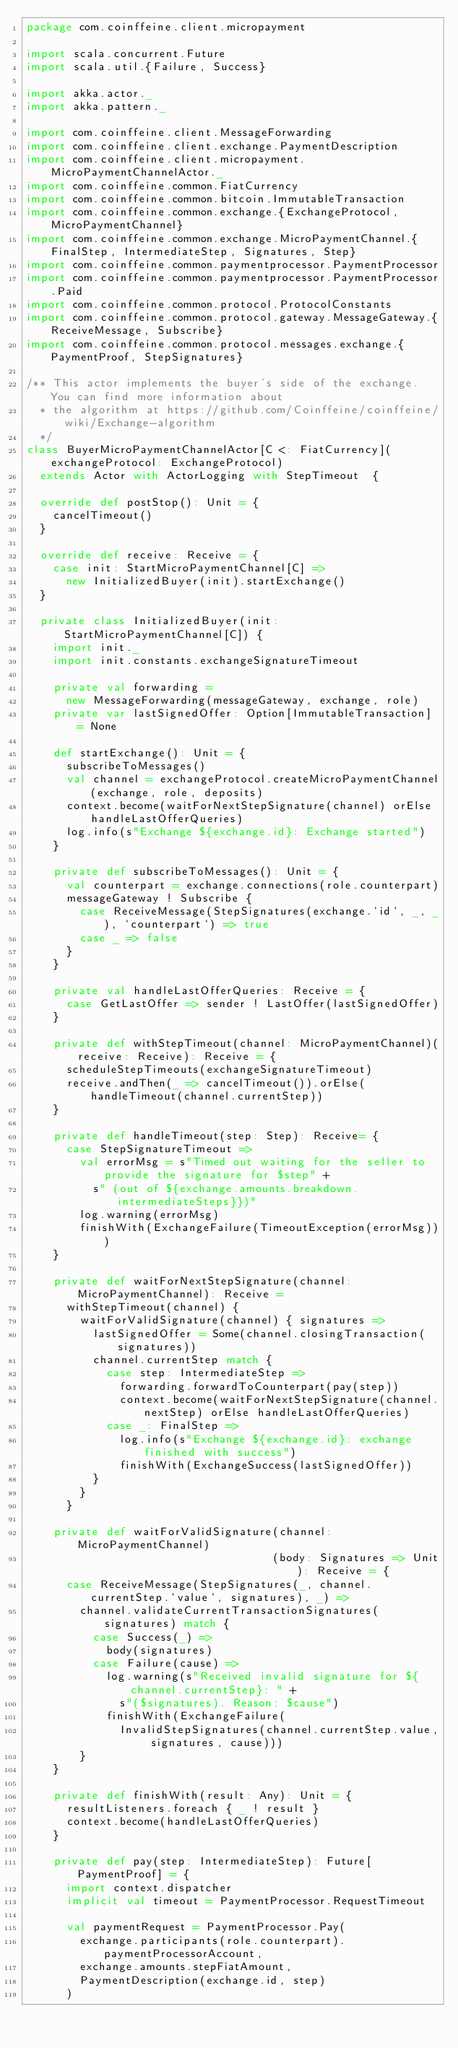<code> <loc_0><loc_0><loc_500><loc_500><_Scala_>package com.coinffeine.client.micropayment

import scala.concurrent.Future
import scala.util.{Failure, Success}

import akka.actor._
import akka.pattern._

import com.coinffeine.client.MessageForwarding
import com.coinffeine.client.exchange.PaymentDescription
import com.coinffeine.client.micropayment.MicroPaymentChannelActor._
import com.coinffeine.common.FiatCurrency
import com.coinffeine.common.bitcoin.ImmutableTransaction
import com.coinffeine.common.exchange.{ExchangeProtocol, MicroPaymentChannel}
import com.coinffeine.common.exchange.MicroPaymentChannel.{FinalStep, IntermediateStep, Signatures, Step}
import com.coinffeine.common.paymentprocessor.PaymentProcessor
import com.coinffeine.common.paymentprocessor.PaymentProcessor.Paid
import com.coinffeine.common.protocol.ProtocolConstants
import com.coinffeine.common.protocol.gateway.MessageGateway.{ReceiveMessage, Subscribe}
import com.coinffeine.common.protocol.messages.exchange.{PaymentProof, StepSignatures}

/** This actor implements the buyer's side of the exchange. You can find more information about
  * the algorithm at https://github.com/Coinffeine/coinffeine/wiki/Exchange-algorithm
  */
class BuyerMicroPaymentChannelActor[C <: FiatCurrency](exchangeProtocol: ExchangeProtocol)
  extends Actor with ActorLogging with StepTimeout  {

  override def postStop(): Unit = {
    cancelTimeout()
  }

  override def receive: Receive = {
    case init: StartMicroPaymentChannel[C] =>
      new InitializedBuyer(init).startExchange()
  }

  private class InitializedBuyer(init: StartMicroPaymentChannel[C]) {
    import init._
    import init.constants.exchangeSignatureTimeout

    private val forwarding =
      new MessageForwarding(messageGateway, exchange, role)
    private var lastSignedOffer: Option[ImmutableTransaction] = None

    def startExchange(): Unit = {
      subscribeToMessages()
      val channel = exchangeProtocol.createMicroPaymentChannel(exchange, role, deposits)
      context.become(waitForNextStepSignature(channel) orElse handleLastOfferQueries)
      log.info(s"Exchange ${exchange.id}: Exchange started")
    }

    private def subscribeToMessages(): Unit = {
      val counterpart = exchange.connections(role.counterpart)
      messageGateway ! Subscribe {
        case ReceiveMessage(StepSignatures(exchange.`id`, _, _), `counterpart`) => true
        case _ => false
      }
    }

    private val handleLastOfferQueries: Receive = {
      case GetLastOffer => sender ! LastOffer(lastSignedOffer)
    }

    private def withStepTimeout(channel: MicroPaymentChannel)(receive: Receive): Receive = {
      scheduleStepTimeouts(exchangeSignatureTimeout)
      receive.andThen(_ => cancelTimeout()).orElse(handleTimeout(channel.currentStep))
    }

    private def handleTimeout(step: Step): Receive= {
      case StepSignatureTimeout =>
        val errorMsg = s"Timed out waiting for the seller to provide the signature for $step" +
          s" (out of ${exchange.amounts.breakdown.intermediateSteps}})"
        log.warning(errorMsg)
        finishWith(ExchangeFailure(TimeoutException(errorMsg)))
    }

    private def waitForNextStepSignature(channel: MicroPaymentChannel): Receive =
      withStepTimeout(channel) {
        waitForValidSignature(channel) { signatures =>
          lastSignedOffer = Some(channel.closingTransaction(signatures))
          channel.currentStep match {
            case step: IntermediateStep =>
              forwarding.forwardToCounterpart(pay(step))
              context.become(waitForNextStepSignature(channel.nextStep) orElse handleLastOfferQueries)
            case _: FinalStep =>
              log.info(s"Exchange ${exchange.id}: exchange finished with success")
              finishWith(ExchangeSuccess(lastSignedOffer))
          }
        }
      }

    private def waitForValidSignature(channel: MicroPaymentChannel)
                                     (body: Signatures => Unit): Receive = {
      case ReceiveMessage(StepSignatures(_, channel.currentStep.`value`, signatures), _) =>
        channel.validateCurrentTransactionSignatures(signatures) match {
          case Success(_) =>
            body(signatures)
          case Failure(cause) =>
            log.warning(s"Received invalid signature for ${channel.currentStep}: " +
              s"($signatures). Reason: $cause")
            finishWith(ExchangeFailure(
              InvalidStepSignatures(channel.currentStep.value, signatures, cause)))
        }
    }

    private def finishWith(result: Any): Unit = {
      resultListeners.foreach { _ ! result }
      context.become(handleLastOfferQueries)
    }

    private def pay(step: IntermediateStep): Future[PaymentProof] = {
      import context.dispatcher
      implicit val timeout = PaymentProcessor.RequestTimeout

      val paymentRequest = PaymentProcessor.Pay(
        exchange.participants(role.counterpart).paymentProcessorAccount,
        exchange.amounts.stepFiatAmount,
        PaymentDescription(exchange.id, step)
      )</code> 